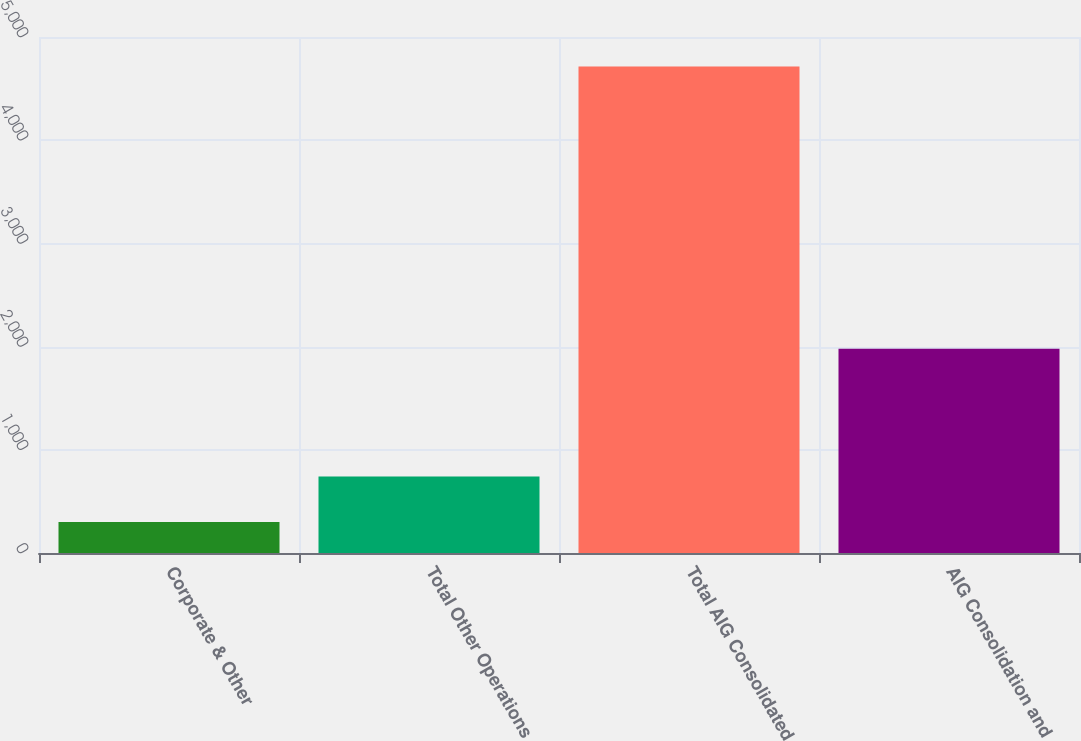Convert chart to OTSL. <chart><loc_0><loc_0><loc_500><loc_500><bar_chart><fcel>Corporate & Other<fcel>Total Other Operations<fcel>Total AIG Consolidated<fcel>AIG Consolidation and<nl><fcel>300<fcel>741.3<fcel>4713<fcel>1980<nl></chart> 